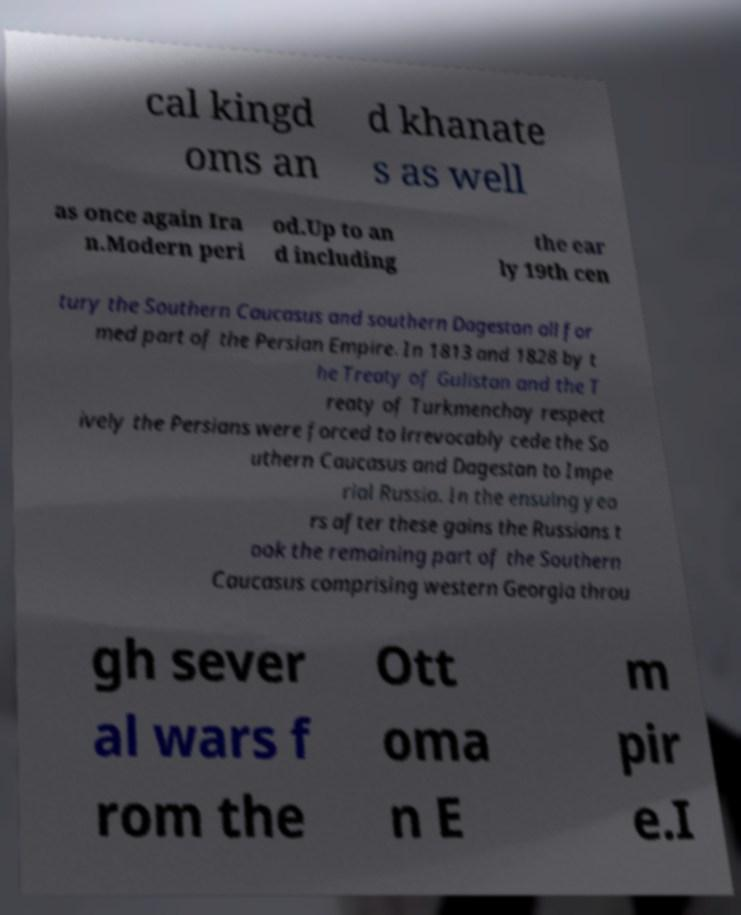I need the written content from this picture converted into text. Can you do that? cal kingd oms an d khanate s as well as once again Ira n.Modern peri od.Up to an d including the ear ly 19th cen tury the Southern Caucasus and southern Dagestan all for med part of the Persian Empire. In 1813 and 1828 by t he Treaty of Gulistan and the T reaty of Turkmenchay respect ively the Persians were forced to irrevocably cede the So uthern Caucasus and Dagestan to Impe rial Russia. In the ensuing yea rs after these gains the Russians t ook the remaining part of the Southern Caucasus comprising western Georgia throu gh sever al wars f rom the Ott oma n E m pir e.I 